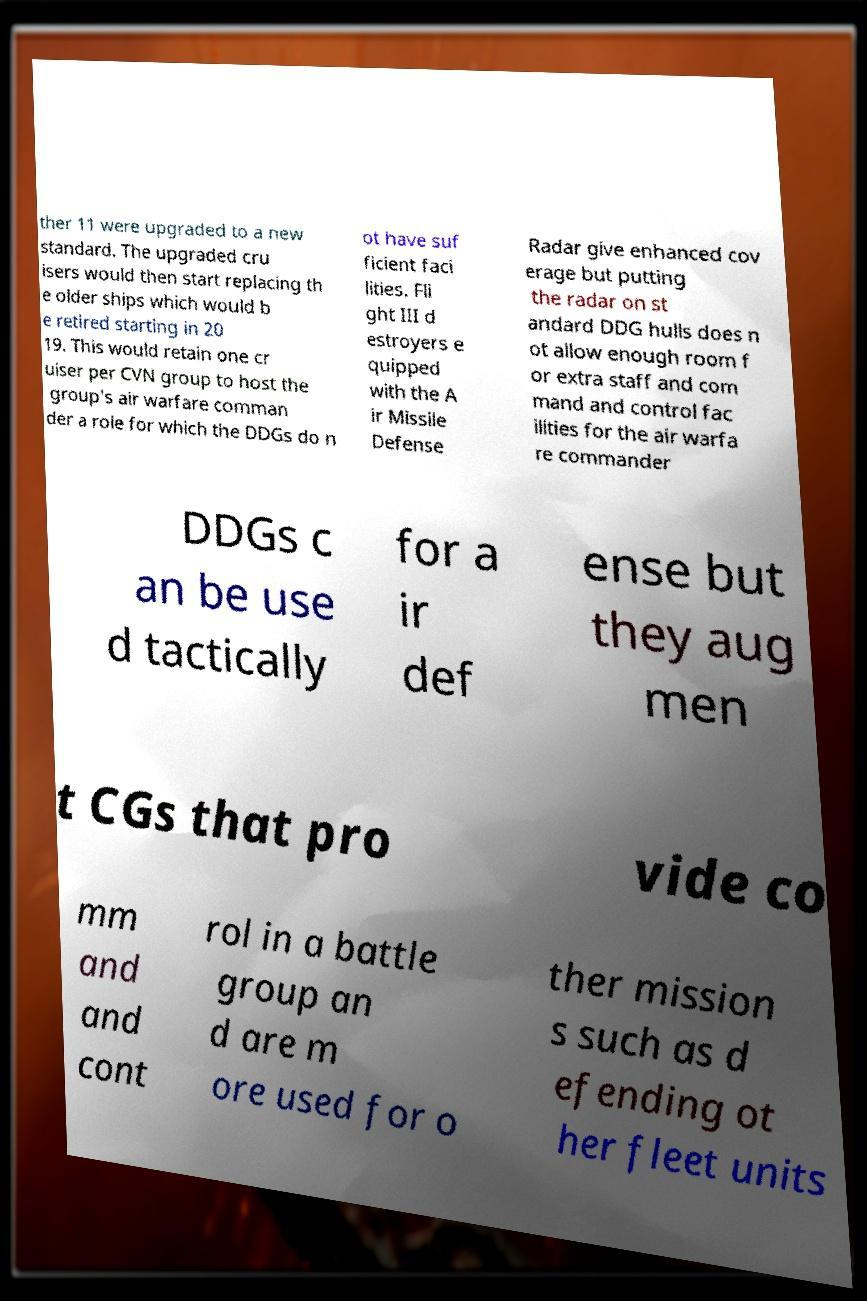For documentation purposes, I need the text within this image transcribed. Could you provide that? ther 11 were upgraded to a new standard. The upgraded cru isers would then start replacing th e older ships which would b e retired starting in 20 19. This would retain one cr uiser per CVN group to host the group's air warfare comman der a role for which the DDGs do n ot have suf ficient faci lities. Fli ght III d estroyers e quipped with the A ir Missile Defense Radar give enhanced cov erage but putting the radar on st andard DDG hulls does n ot allow enough room f or extra staff and com mand and control fac ilities for the air warfa re commander DDGs c an be use d tactically for a ir def ense but they aug men t CGs that pro vide co mm and and cont rol in a battle group an d are m ore used for o ther mission s such as d efending ot her fleet units 